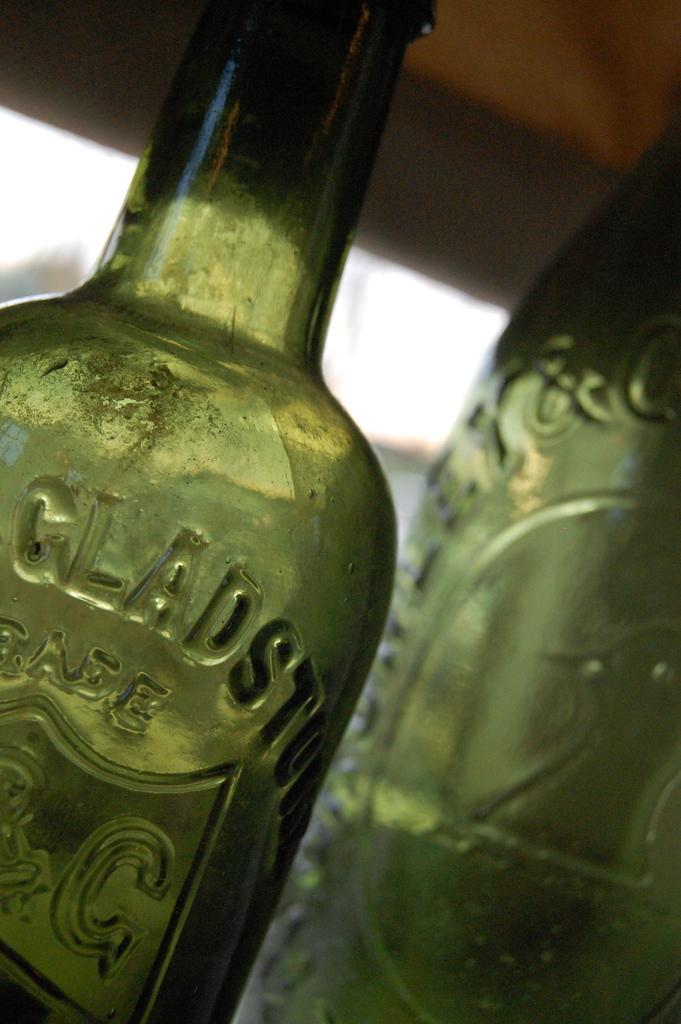Can you describe this image briefly? In this image I can see two green color bottles. The background is blurred. 